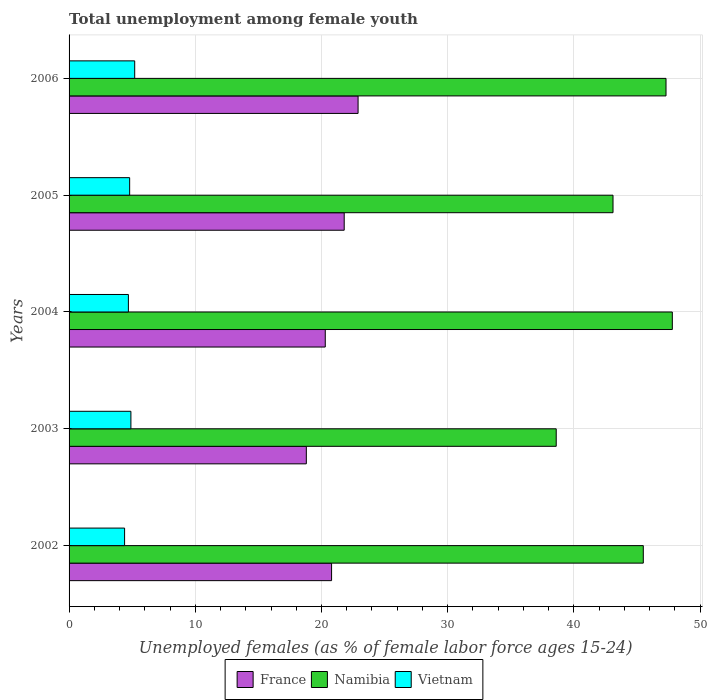Are the number of bars per tick equal to the number of legend labels?
Offer a terse response. Yes. How many bars are there on the 3rd tick from the top?
Your response must be concise. 3. What is the label of the 2nd group of bars from the top?
Make the answer very short. 2005. What is the percentage of unemployed females in in Vietnam in 2004?
Ensure brevity in your answer.  4.7. Across all years, what is the maximum percentage of unemployed females in in France?
Your response must be concise. 22.9. Across all years, what is the minimum percentage of unemployed females in in Vietnam?
Provide a short and direct response. 4.4. In which year was the percentage of unemployed females in in Vietnam maximum?
Offer a very short reply. 2006. What is the total percentage of unemployed females in in Vietnam in the graph?
Give a very brief answer. 24. What is the difference between the percentage of unemployed females in in Namibia in 2002 and that in 2003?
Give a very brief answer. 6.9. What is the difference between the percentage of unemployed females in in Vietnam in 2004 and the percentage of unemployed females in in Namibia in 2006?
Ensure brevity in your answer.  -42.6. What is the average percentage of unemployed females in in Namibia per year?
Make the answer very short. 44.46. In the year 2003, what is the difference between the percentage of unemployed females in in Vietnam and percentage of unemployed females in in Namibia?
Make the answer very short. -33.7. In how many years, is the percentage of unemployed females in in Vietnam greater than 20 %?
Make the answer very short. 0. What is the ratio of the percentage of unemployed females in in France in 2002 to that in 2005?
Offer a terse response. 0.95. Is the difference between the percentage of unemployed females in in Vietnam in 2002 and 2006 greater than the difference between the percentage of unemployed females in in Namibia in 2002 and 2006?
Make the answer very short. Yes. What is the difference between the highest and the second highest percentage of unemployed females in in Namibia?
Your answer should be compact. 0.5. What is the difference between the highest and the lowest percentage of unemployed females in in Vietnam?
Ensure brevity in your answer.  0.8. In how many years, is the percentage of unemployed females in in Vietnam greater than the average percentage of unemployed females in in Vietnam taken over all years?
Make the answer very short. 3. Is the sum of the percentage of unemployed females in in Vietnam in 2003 and 2006 greater than the maximum percentage of unemployed females in in France across all years?
Keep it short and to the point. No. What does the 2nd bar from the top in 2002 represents?
Provide a succinct answer. Namibia. What does the 3rd bar from the bottom in 2006 represents?
Offer a terse response. Vietnam. Are all the bars in the graph horizontal?
Offer a very short reply. Yes. What is the difference between two consecutive major ticks on the X-axis?
Provide a succinct answer. 10. Does the graph contain any zero values?
Provide a short and direct response. No. Does the graph contain grids?
Offer a terse response. Yes. Where does the legend appear in the graph?
Your answer should be compact. Bottom center. How many legend labels are there?
Your answer should be very brief. 3. What is the title of the graph?
Offer a terse response. Total unemployment among female youth. Does "Uruguay" appear as one of the legend labels in the graph?
Your answer should be very brief. No. What is the label or title of the X-axis?
Give a very brief answer. Unemployed females (as % of female labor force ages 15-24). What is the Unemployed females (as % of female labor force ages 15-24) of France in 2002?
Offer a terse response. 20.8. What is the Unemployed females (as % of female labor force ages 15-24) of Namibia in 2002?
Give a very brief answer. 45.5. What is the Unemployed females (as % of female labor force ages 15-24) in Vietnam in 2002?
Ensure brevity in your answer.  4.4. What is the Unemployed females (as % of female labor force ages 15-24) of France in 2003?
Your answer should be compact. 18.8. What is the Unemployed females (as % of female labor force ages 15-24) of Namibia in 2003?
Your answer should be compact. 38.6. What is the Unemployed females (as % of female labor force ages 15-24) in Vietnam in 2003?
Offer a terse response. 4.9. What is the Unemployed females (as % of female labor force ages 15-24) of France in 2004?
Keep it short and to the point. 20.3. What is the Unemployed females (as % of female labor force ages 15-24) of Namibia in 2004?
Your answer should be very brief. 47.8. What is the Unemployed females (as % of female labor force ages 15-24) in Vietnam in 2004?
Make the answer very short. 4.7. What is the Unemployed females (as % of female labor force ages 15-24) of France in 2005?
Keep it short and to the point. 21.8. What is the Unemployed females (as % of female labor force ages 15-24) of Namibia in 2005?
Provide a short and direct response. 43.1. What is the Unemployed females (as % of female labor force ages 15-24) of Vietnam in 2005?
Make the answer very short. 4.8. What is the Unemployed females (as % of female labor force ages 15-24) in France in 2006?
Offer a very short reply. 22.9. What is the Unemployed females (as % of female labor force ages 15-24) of Namibia in 2006?
Your answer should be very brief. 47.3. What is the Unemployed females (as % of female labor force ages 15-24) of Vietnam in 2006?
Provide a short and direct response. 5.2. Across all years, what is the maximum Unemployed females (as % of female labor force ages 15-24) in France?
Make the answer very short. 22.9. Across all years, what is the maximum Unemployed females (as % of female labor force ages 15-24) of Namibia?
Keep it short and to the point. 47.8. Across all years, what is the maximum Unemployed females (as % of female labor force ages 15-24) of Vietnam?
Offer a very short reply. 5.2. Across all years, what is the minimum Unemployed females (as % of female labor force ages 15-24) of France?
Your answer should be very brief. 18.8. Across all years, what is the minimum Unemployed females (as % of female labor force ages 15-24) in Namibia?
Make the answer very short. 38.6. Across all years, what is the minimum Unemployed females (as % of female labor force ages 15-24) of Vietnam?
Give a very brief answer. 4.4. What is the total Unemployed females (as % of female labor force ages 15-24) in France in the graph?
Ensure brevity in your answer.  104.6. What is the total Unemployed females (as % of female labor force ages 15-24) of Namibia in the graph?
Ensure brevity in your answer.  222.3. What is the difference between the Unemployed females (as % of female labor force ages 15-24) in France in 2002 and that in 2003?
Your response must be concise. 2. What is the difference between the Unemployed females (as % of female labor force ages 15-24) in France in 2002 and that in 2004?
Offer a terse response. 0.5. What is the difference between the Unemployed females (as % of female labor force ages 15-24) of Namibia in 2002 and that in 2004?
Your response must be concise. -2.3. What is the difference between the Unemployed females (as % of female labor force ages 15-24) in France in 2002 and that in 2005?
Your response must be concise. -1. What is the difference between the Unemployed females (as % of female labor force ages 15-24) in Vietnam in 2002 and that in 2005?
Provide a short and direct response. -0.4. What is the difference between the Unemployed females (as % of female labor force ages 15-24) of France in 2002 and that in 2006?
Your response must be concise. -2.1. What is the difference between the Unemployed females (as % of female labor force ages 15-24) of Vietnam in 2002 and that in 2006?
Provide a succinct answer. -0.8. What is the difference between the Unemployed females (as % of female labor force ages 15-24) of France in 2003 and that in 2005?
Provide a short and direct response. -3. What is the difference between the Unemployed females (as % of female labor force ages 15-24) of Vietnam in 2004 and that in 2005?
Give a very brief answer. -0.1. What is the difference between the Unemployed females (as % of female labor force ages 15-24) in Vietnam in 2004 and that in 2006?
Offer a very short reply. -0.5. What is the difference between the Unemployed females (as % of female labor force ages 15-24) of France in 2005 and that in 2006?
Your answer should be compact. -1.1. What is the difference between the Unemployed females (as % of female labor force ages 15-24) in France in 2002 and the Unemployed females (as % of female labor force ages 15-24) in Namibia in 2003?
Your answer should be very brief. -17.8. What is the difference between the Unemployed females (as % of female labor force ages 15-24) of France in 2002 and the Unemployed females (as % of female labor force ages 15-24) of Vietnam in 2003?
Ensure brevity in your answer.  15.9. What is the difference between the Unemployed females (as % of female labor force ages 15-24) in Namibia in 2002 and the Unemployed females (as % of female labor force ages 15-24) in Vietnam in 2003?
Your answer should be compact. 40.6. What is the difference between the Unemployed females (as % of female labor force ages 15-24) of France in 2002 and the Unemployed females (as % of female labor force ages 15-24) of Namibia in 2004?
Offer a terse response. -27. What is the difference between the Unemployed females (as % of female labor force ages 15-24) in France in 2002 and the Unemployed females (as % of female labor force ages 15-24) in Vietnam in 2004?
Ensure brevity in your answer.  16.1. What is the difference between the Unemployed females (as % of female labor force ages 15-24) in Namibia in 2002 and the Unemployed females (as % of female labor force ages 15-24) in Vietnam in 2004?
Your answer should be very brief. 40.8. What is the difference between the Unemployed females (as % of female labor force ages 15-24) of France in 2002 and the Unemployed females (as % of female labor force ages 15-24) of Namibia in 2005?
Keep it short and to the point. -22.3. What is the difference between the Unemployed females (as % of female labor force ages 15-24) in France in 2002 and the Unemployed females (as % of female labor force ages 15-24) in Vietnam in 2005?
Provide a short and direct response. 16. What is the difference between the Unemployed females (as % of female labor force ages 15-24) of Namibia in 2002 and the Unemployed females (as % of female labor force ages 15-24) of Vietnam in 2005?
Provide a succinct answer. 40.7. What is the difference between the Unemployed females (as % of female labor force ages 15-24) in France in 2002 and the Unemployed females (as % of female labor force ages 15-24) in Namibia in 2006?
Offer a very short reply. -26.5. What is the difference between the Unemployed females (as % of female labor force ages 15-24) of France in 2002 and the Unemployed females (as % of female labor force ages 15-24) of Vietnam in 2006?
Your answer should be compact. 15.6. What is the difference between the Unemployed females (as % of female labor force ages 15-24) of Namibia in 2002 and the Unemployed females (as % of female labor force ages 15-24) of Vietnam in 2006?
Keep it short and to the point. 40.3. What is the difference between the Unemployed females (as % of female labor force ages 15-24) in Namibia in 2003 and the Unemployed females (as % of female labor force ages 15-24) in Vietnam in 2004?
Keep it short and to the point. 33.9. What is the difference between the Unemployed females (as % of female labor force ages 15-24) in France in 2003 and the Unemployed females (as % of female labor force ages 15-24) in Namibia in 2005?
Offer a very short reply. -24.3. What is the difference between the Unemployed females (as % of female labor force ages 15-24) of Namibia in 2003 and the Unemployed females (as % of female labor force ages 15-24) of Vietnam in 2005?
Your answer should be compact. 33.8. What is the difference between the Unemployed females (as % of female labor force ages 15-24) in France in 2003 and the Unemployed females (as % of female labor force ages 15-24) in Namibia in 2006?
Make the answer very short. -28.5. What is the difference between the Unemployed females (as % of female labor force ages 15-24) in France in 2003 and the Unemployed females (as % of female labor force ages 15-24) in Vietnam in 2006?
Offer a very short reply. 13.6. What is the difference between the Unemployed females (as % of female labor force ages 15-24) in Namibia in 2003 and the Unemployed females (as % of female labor force ages 15-24) in Vietnam in 2006?
Your response must be concise. 33.4. What is the difference between the Unemployed females (as % of female labor force ages 15-24) of France in 2004 and the Unemployed females (as % of female labor force ages 15-24) of Namibia in 2005?
Your response must be concise. -22.8. What is the difference between the Unemployed females (as % of female labor force ages 15-24) in France in 2004 and the Unemployed females (as % of female labor force ages 15-24) in Vietnam in 2005?
Keep it short and to the point. 15.5. What is the difference between the Unemployed females (as % of female labor force ages 15-24) in Namibia in 2004 and the Unemployed females (as % of female labor force ages 15-24) in Vietnam in 2005?
Make the answer very short. 43. What is the difference between the Unemployed females (as % of female labor force ages 15-24) in France in 2004 and the Unemployed females (as % of female labor force ages 15-24) in Vietnam in 2006?
Provide a succinct answer. 15.1. What is the difference between the Unemployed females (as % of female labor force ages 15-24) of Namibia in 2004 and the Unemployed females (as % of female labor force ages 15-24) of Vietnam in 2006?
Your answer should be compact. 42.6. What is the difference between the Unemployed females (as % of female labor force ages 15-24) of France in 2005 and the Unemployed females (as % of female labor force ages 15-24) of Namibia in 2006?
Offer a very short reply. -25.5. What is the difference between the Unemployed females (as % of female labor force ages 15-24) of France in 2005 and the Unemployed females (as % of female labor force ages 15-24) of Vietnam in 2006?
Keep it short and to the point. 16.6. What is the difference between the Unemployed females (as % of female labor force ages 15-24) of Namibia in 2005 and the Unemployed females (as % of female labor force ages 15-24) of Vietnam in 2006?
Keep it short and to the point. 37.9. What is the average Unemployed females (as % of female labor force ages 15-24) of France per year?
Keep it short and to the point. 20.92. What is the average Unemployed females (as % of female labor force ages 15-24) in Namibia per year?
Your answer should be compact. 44.46. In the year 2002, what is the difference between the Unemployed females (as % of female labor force ages 15-24) in France and Unemployed females (as % of female labor force ages 15-24) in Namibia?
Keep it short and to the point. -24.7. In the year 2002, what is the difference between the Unemployed females (as % of female labor force ages 15-24) of France and Unemployed females (as % of female labor force ages 15-24) of Vietnam?
Ensure brevity in your answer.  16.4. In the year 2002, what is the difference between the Unemployed females (as % of female labor force ages 15-24) of Namibia and Unemployed females (as % of female labor force ages 15-24) of Vietnam?
Keep it short and to the point. 41.1. In the year 2003, what is the difference between the Unemployed females (as % of female labor force ages 15-24) in France and Unemployed females (as % of female labor force ages 15-24) in Namibia?
Keep it short and to the point. -19.8. In the year 2003, what is the difference between the Unemployed females (as % of female labor force ages 15-24) of Namibia and Unemployed females (as % of female labor force ages 15-24) of Vietnam?
Keep it short and to the point. 33.7. In the year 2004, what is the difference between the Unemployed females (as % of female labor force ages 15-24) of France and Unemployed females (as % of female labor force ages 15-24) of Namibia?
Provide a succinct answer. -27.5. In the year 2004, what is the difference between the Unemployed females (as % of female labor force ages 15-24) of Namibia and Unemployed females (as % of female labor force ages 15-24) of Vietnam?
Your answer should be very brief. 43.1. In the year 2005, what is the difference between the Unemployed females (as % of female labor force ages 15-24) in France and Unemployed females (as % of female labor force ages 15-24) in Namibia?
Offer a terse response. -21.3. In the year 2005, what is the difference between the Unemployed females (as % of female labor force ages 15-24) in Namibia and Unemployed females (as % of female labor force ages 15-24) in Vietnam?
Offer a terse response. 38.3. In the year 2006, what is the difference between the Unemployed females (as % of female labor force ages 15-24) in France and Unemployed females (as % of female labor force ages 15-24) in Namibia?
Provide a succinct answer. -24.4. In the year 2006, what is the difference between the Unemployed females (as % of female labor force ages 15-24) in Namibia and Unemployed females (as % of female labor force ages 15-24) in Vietnam?
Provide a short and direct response. 42.1. What is the ratio of the Unemployed females (as % of female labor force ages 15-24) in France in 2002 to that in 2003?
Your answer should be very brief. 1.11. What is the ratio of the Unemployed females (as % of female labor force ages 15-24) in Namibia in 2002 to that in 2003?
Your answer should be compact. 1.18. What is the ratio of the Unemployed females (as % of female labor force ages 15-24) in Vietnam in 2002 to that in 2003?
Provide a short and direct response. 0.9. What is the ratio of the Unemployed females (as % of female labor force ages 15-24) in France in 2002 to that in 2004?
Ensure brevity in your answer.  1.02. What is the ratio of the Unemployed females (as % of female labor force ages 15-24) of Namibia in 2002 to that in 2004?
Your response must be concise. 0.95. What is the ratio of the Unemployed females (as % of female labor force ages 15-24) in Vietnam in 2002 to that in 2004?
Provide a short and direct response. 0.94. What is the ratio of the Unemployed females (as % of female labor force ages 15-24) in France in 2002 to that in 2005?
Provide a short and direct response. 0.95. What is the ratio of the Unemployed females (as % of female labor force ages 15-24) of Namibia in 2002 to that in 2005?
Your answer should be compact. 1.06. What is the ratio of the Unemployed females (as % of female labor force ages 15-24) of Vietnam in 2002 to that in 2005?
Keep it short and to the point. 0.92. What is the ratio of the Unemployed females (as % of female labor force ages 15-24) in France in 2002 to that in 2006?
Your answer should be very brief. 0.91. What is the ratio of the Unemployed females (as % of female labor force ages 15-24) of Namibia in 2002 to that in 2006?
Provide a short and direct response. 0.96. What is the ratio of the Unemployed females (as % of female labor force ages 15-24) of Vietnam in 2002 to that in 2006?
Offer a very short reply. 0.85. What is the ratio of the Unemployed females (as % of female labor force ages 15-24) in France in 2003 to that in 2004?
Your answer should be compact. 0.93. What is the ratio of the Unemployed females (as % of female labor force ages 15-24) of Namibia in 2003 to that in 2004?
Your response must be concise. 0.81. What is the ratio of the Unemployed females (as % of female labor force ages 15-24) in Vietnam in 2003 to that in 2004?
Your answer should be compact. 1.04. What is the ratio of the Unemployed females (as % of female labor force ages 15-24) of France in 2003 to that in 2005?
Offer a terse response. 0.86. What is the ratio of the Unemployed females (as % of female labor force ages 15-24) in Namibia in 2003 to that in 2005?
Ensure brevity in your answer.  0.9. What is the ratio of the Unemployed females (as % of female labor force ages 15-24) of Vietnam in 2003 to that in 2005?
Give a very brief answer. 1.02. What is the ratio of the Unemployed females (as % of female labor force ages 15-24) in France in 2003 to that in 2006?
Give a very brief answer. 0.82. What is the ratio of the Unemployed females (as % of female labor force ages 15-24) of Namibia in 2003 to that in 2006?
Keep it short and to the point. 0.82. What is the ratio of the Unemployed females (as % of female labor force ages 15-24) in Vietnam in 2003 to that in 2006?
Your answer should be very brief. 0.94. What is the ratio of the Unemployed females (as % of female labor force ages 15-24) in France in 2004 to that in 2005?
Your response must be concise. 0.93. What is the ratio of the Unemployed females (as % of female labor force ages 15-24) of Namibia in 2004 to that in 2005?
Make the answer very short. 1.11. What is the ratio of the Unemployed females (as % of female labor force ages 15-24) of Vietnam in 2004 to that in 2005?
Keep it short and to the point. 0.98. What is the ratio of the Unemployed females (as % of female labor force ages 15-24) of France in 2004 to that in 2006?
Keep it short and to the point. 0.89. What is the ratio of the Unemployed females (as % of female labor force ages 15-24) of Namibia in 2004 to that in 2006?
Your answer should be compact. 1.01. What is the ratio of the Unemployed females (as % of female labor force ages 15-24) in Vietnam in 2004 to that in 2006?
Ensure brevity in your answer.  0.9. What is the ratio of the Unemployed females (as % of female labor force ages 15-24) in France in 2005 to that in 2006?
Give a very brief answer. 0.95. What is the ratio of the Unemployed females (as % of female labor force ages 15-24) of Namibia in 2005 to that in 2006?
Provide a short and direct response. 0.91. What is the ratio of the Unemployed females (as % of female labor force ages 15-24) of Vietnam in 2005 to that in 2006?
Provide a short and direct response. 0.92. What is the difference between the highest and the second highest Unemployed females (as % of female labor force ages 15-24) of Namibia?
Keep it short and to the point. 0.5. What is the difference between the highest and the second highest Unemployed females (as % of female labor force ages 15-24) in Vietnam?
Offer a very short reply. 0.3. What is the difference between the highest and the lowest Unemployed females (as % of female labor force ages 15-24) in France?
Your answer should be compact. 4.1. What is the difference between the highest and the lowest Unemployed females (as % of female labor force ages 15-24) in Namibia?
Offer a terse response. 9.2. What is the difference between the highest and the lowest Unemployed females (as % of female labor force ages 15-24) of Vietnam?
Make the answer very short. 0.8. 